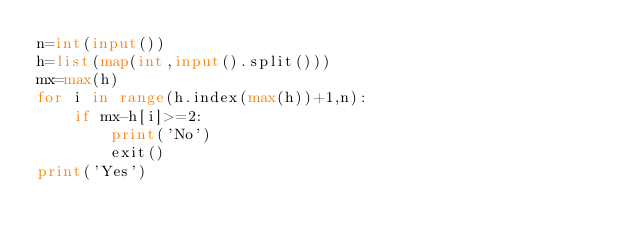Convert code to text. <code><loc_0><loc_0><loc_500><loc_500><_Python_>n=int(input())
h=list(map(int,input().split()))
mx=max(h)
for i in range(h.index(max(h))+1,n):
    if mx-h[i]>=2:
        print('No')
        exit()
print('Yes')</code> 